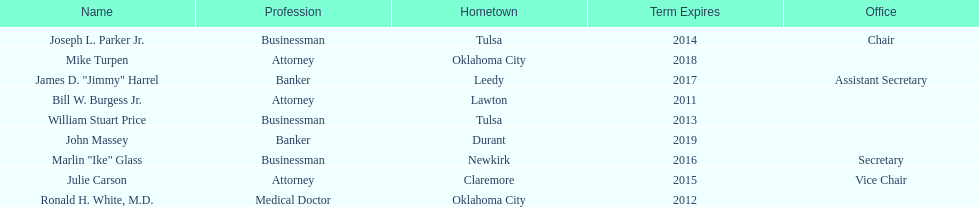What is the total number of state regents who are attorneys? 3. 